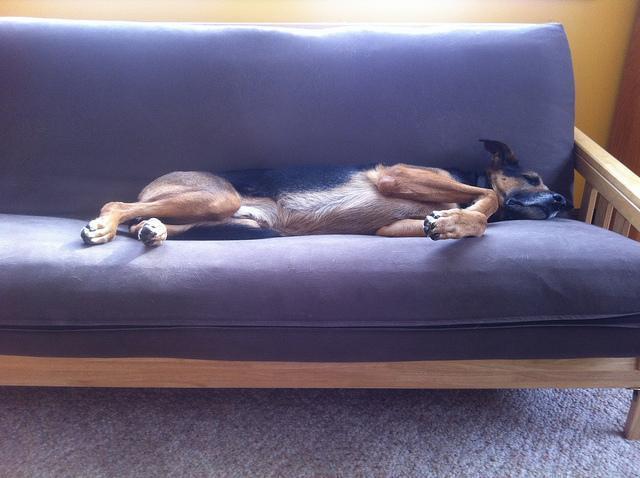How many couches are there?
Give a very brief answer. 1. 